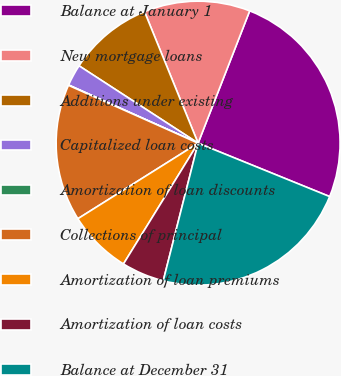Convert chart. <chart><loc_0><loc_0><loc_500><loc_500><pie_chart><fcel>Balance at January 1<fcel>New mortgage loans<fcel>Additions under existing<fcel>Capitalized loan costs<fcel>Amortization of loan discounts<fcel>Collections of principal<fcel>Amortization of loan premiums<fcel>Amortization of loan costs<fcel>Balance at December 31<nl><fcel>25.22%<fcel>12.08%<fcel>9.67%<fcel>2.45%<fcel>0.04%<fcel>15.61%<fcel>7.26%<fcel>4.86%<fcel>22.81%<nl></chart> 